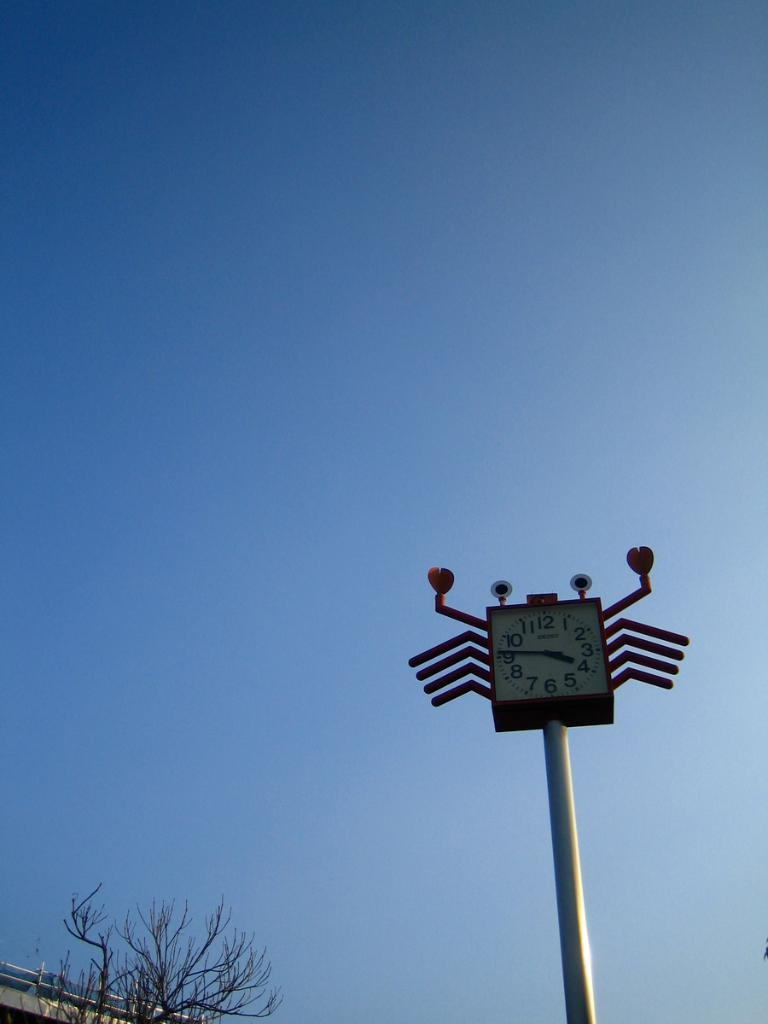What color is the sky in the image? The sky is blue in the image. What object is located at the bottom of the image? There is a pole with a clock at the bottom of the image. Are there any berries growing on the pole with the clock in the image? There are no berries present in the image; it only features a pole with a clock. 